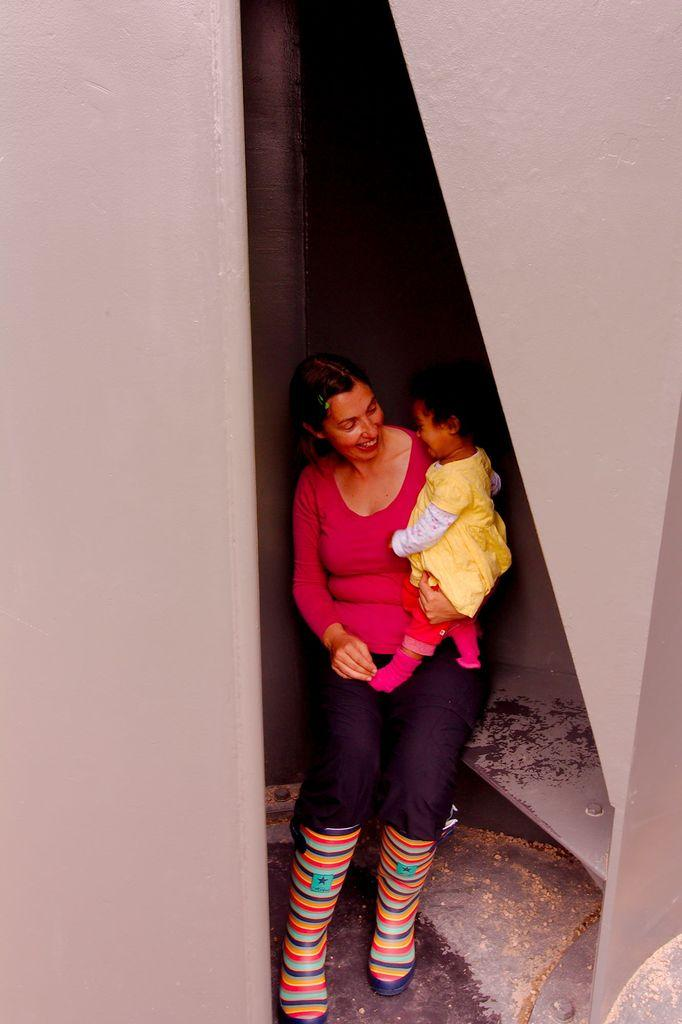What is the main subject of the image? The main subject of the image is a lady. What is the lady doing in the image? The lady is carrying a baby. What can be seen in the background of the image? There are walls visible in the image. What type of answer is the lady giving to the farmer in the image? There is no farmer present in the image, and the lady is not giving any answers. Can you hear the baby crying in the image? The image is a still picture, so it is not possible to hear any sounds, including the baby crying. 